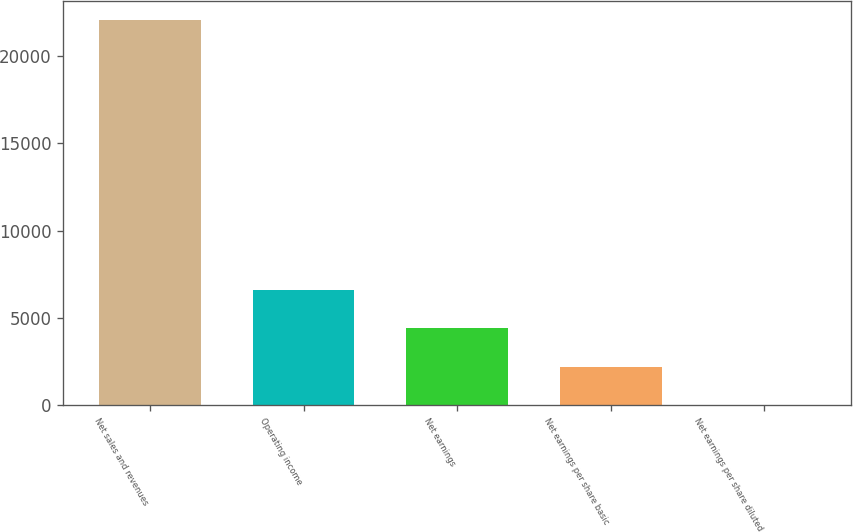Convert chart. <chart><loc_0><loc_0><loc_500><loc_500><bar_chart><fcel>Net sales and revenues<fcel>Operating income<fcel>Net earnings<fcel>Net earnings per share basic<fcel>Net earnings per share diluted<nl><fcel>22046<fcel>6615.88<fcel>4411.58<fcel>2207.28<fcel>2.98<nl></chart> 